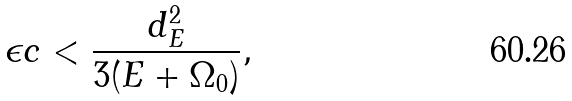<formula> <loc_0><loc_0><loc_500><loc_500>\epsilon c < \frac { d _ { E } ^ { 2 } } { 3 ( E + \Omega _ { 0 } ) } ,</formula> 